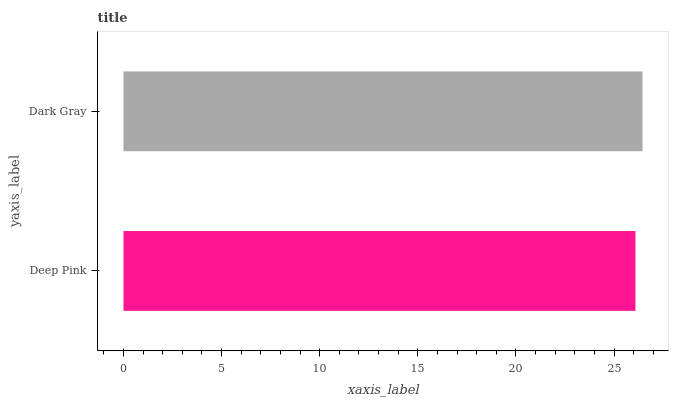Is Deep Pink the minimum?
Answer yes or no. Yes. Is Dark Gray the maximum?
Answer yes or no. Yes. Is Dark Gray the minimum?
Answer yes or no. No. Is Dark Gray greater than Deep Pink?
Answer yes or no. Yes. Is Deep Pink less than Dark Gray?
Answer yes or no. Yes. Is Deep Pink greater than Dark Gray?
Answer yes or no. No. Is Dark Gray less than Deep Pink?
Answer yes or no. No. Is Dark Gray the high median?
Answer yes or no. Yes. Is Deep Pink the low median?
Answer yes or no. Yes. Is Deep Pink the high median?
Answer yes or no. No. Is Dark Gray the low median?
Answer yes or no. No. 